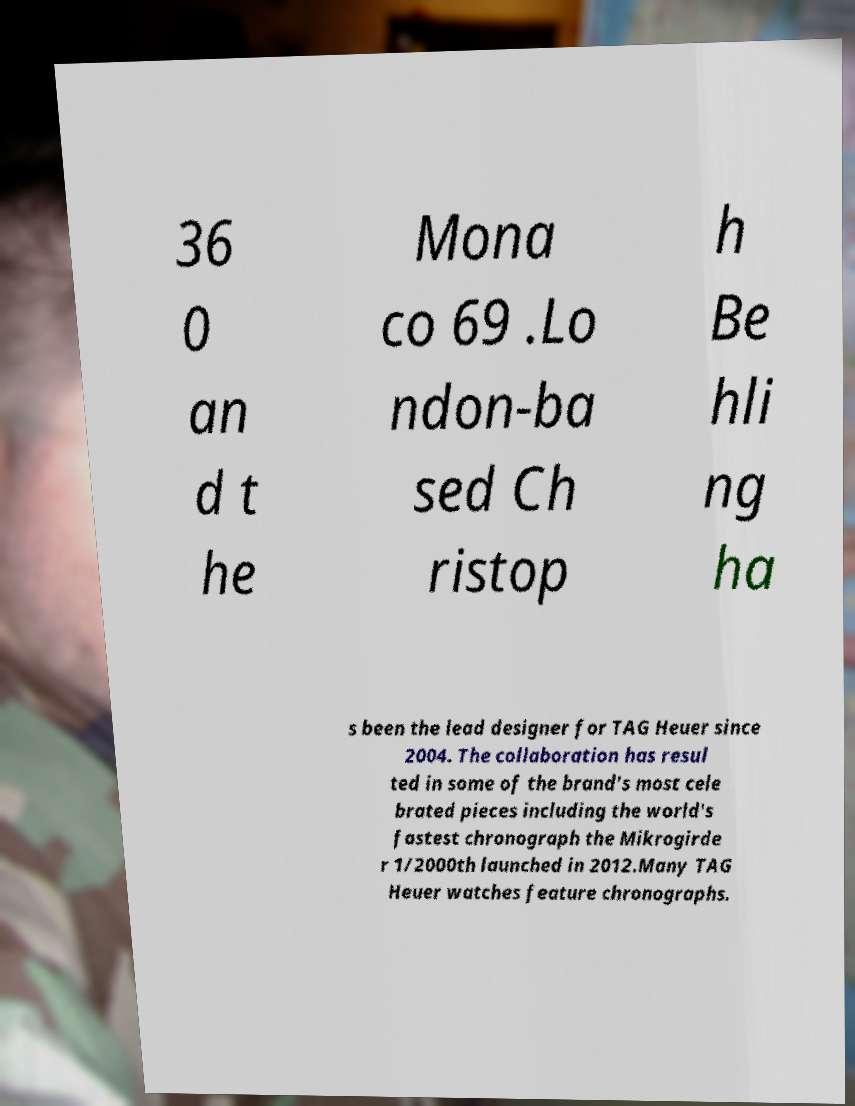I need the written content from this picture converted into text. Can you do that? 36 0 an d t he Mona co 69 .Lo ndon-ba sed Ch ristop h Be hli ng ha s been the lead designer for TAG Heuer since 2004. The collaboration has resul ted in some of the brand's most cele brated pieces including the world's fastest chronograph the Mikrogirde r 1/2000th launched in 2012.Many TAG Heuer watches feature chronographs. 